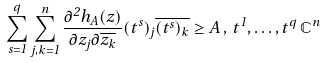<formula> <loc_0><loc_0><loc_500><loc_500>\sum _ { s = 1 } ^ { q } \sum _ { j , k = 1 } ^ { n } \frac { \partial ^ { 2 } h _ { A } ( z ) } { \partial z _ { j } \partial \overline { z _ { k } } } ( t ^ { s } ) _ { j } \overline { ( t ^ { s } ) _ { k } } \geq A \, , \, t ^ { 1 } , \hdots , t ^ { q } \, \mathbb { C } ^ { n }</formula> 